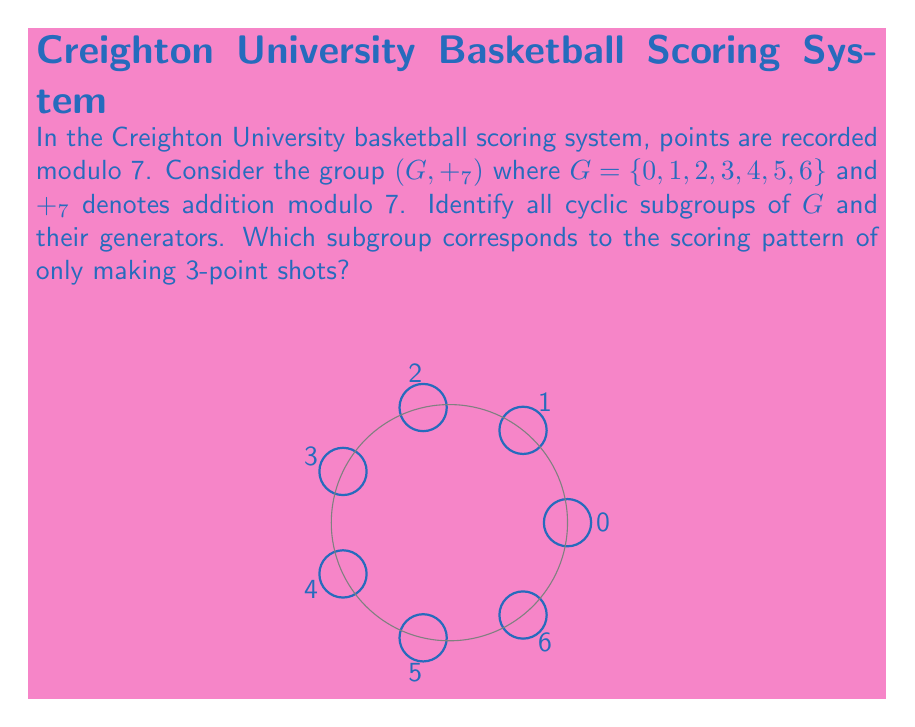Help me with this question. Let's approach this step-by-step:

1) To find cyclic subgroups, we need to generate subgroups from each element of $G$.

2) For each element $a \in G$, we compute $\langle a \rangle = \{ka \mod 7 : k \in \mathbb{Z}\}$:

   $\langle 0 \rangle = \{0\}$
   $\langle 1 \rangle = \{0, 1, 2, 3, 4, 5, 6\}$
   $\langle 2 \rangle = \{0, 2, 4, 6, 1, 3, 5\}$
   $\langle 3 \rangle = \{0, 3, 6, 2, 5, 1, 4\}$
   $\langle 4 \rangle = \{0, 4, 1, 5, 2, 6, 3\}$
   $\langle 5 \rangle = \{0, 5, 3, 1, 6, 4, 2\}$
   $\langle 6 \rangle = \{0, 6, 5, 4, 3, 2, 1\}$

3) We can see that $\langle 1 \rangle, \langle 2 \rangle, \langle 3 \rangle, \langle 4 \rangle, \langle 5 \rangle, \langle 6 \rangle$ all generate the entire group $G$. These are all isomorphic to $\mathbb{Z}_7$.

4) The only proper subgroup is $\langle 0 \rangle = \{0\}$, which is the trivial subgroup.

5) For the scoring pattern of only 3-point shots, we look at $\langle 3 \rangle$. This generates the entire group $G$, meaning that by only scoring 3-pointers, all possible scores modulo 7 can be achieved.
Answer: Cyclic subgroups: $\{0\}$ and $G$. Generators: 0 for $\{0\}$; 1, 2, 3, 4, 5, 6 for $G$. 3-point subgroup: $G$. 